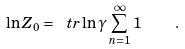<formula> <loc_0><loc_0><loc_500><loc_500>\ln Z _ { 0 } = \ t r \ln \gamma \sum _ { n = 1 } ^ { \infty } 1 \quad .</formula> 